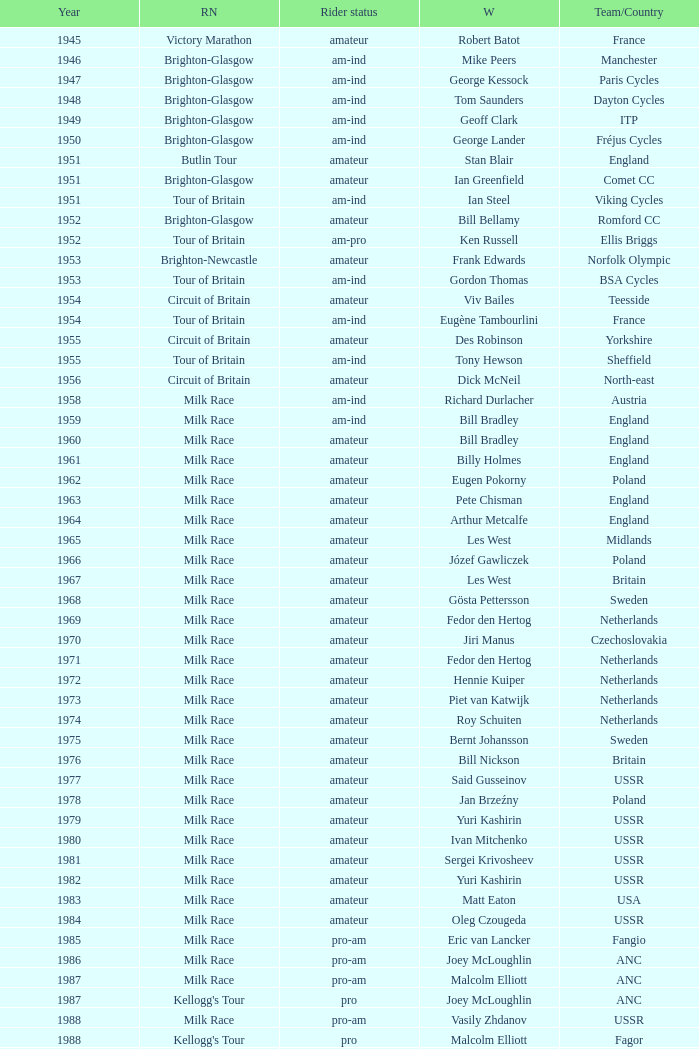What ream played later than 1958 in the kellogg's tour? ANC, Fagor, Z-Peugeot, Weinnmann-SMM, Motorola, Motorola, Motorola, Lampre. 